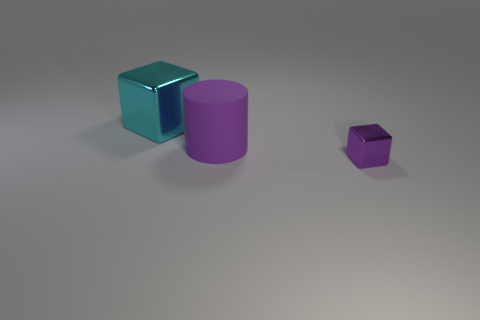Add 2 small purple cubes. How many objects exist? 5 Subtract all cubes. How many objects are left? 1 Add 2 tiny purple shiny things. How many tiny purple shiny things are left? 3 Add 1 tiny gray rubber blocks. How many tiny gray rubber blocks exist? 1 Subtract 0 cyan balls. How many objects are left? 3 Subtract all big cylinders. Subtract all small yellow metal blocks. How many objects are left? 2 